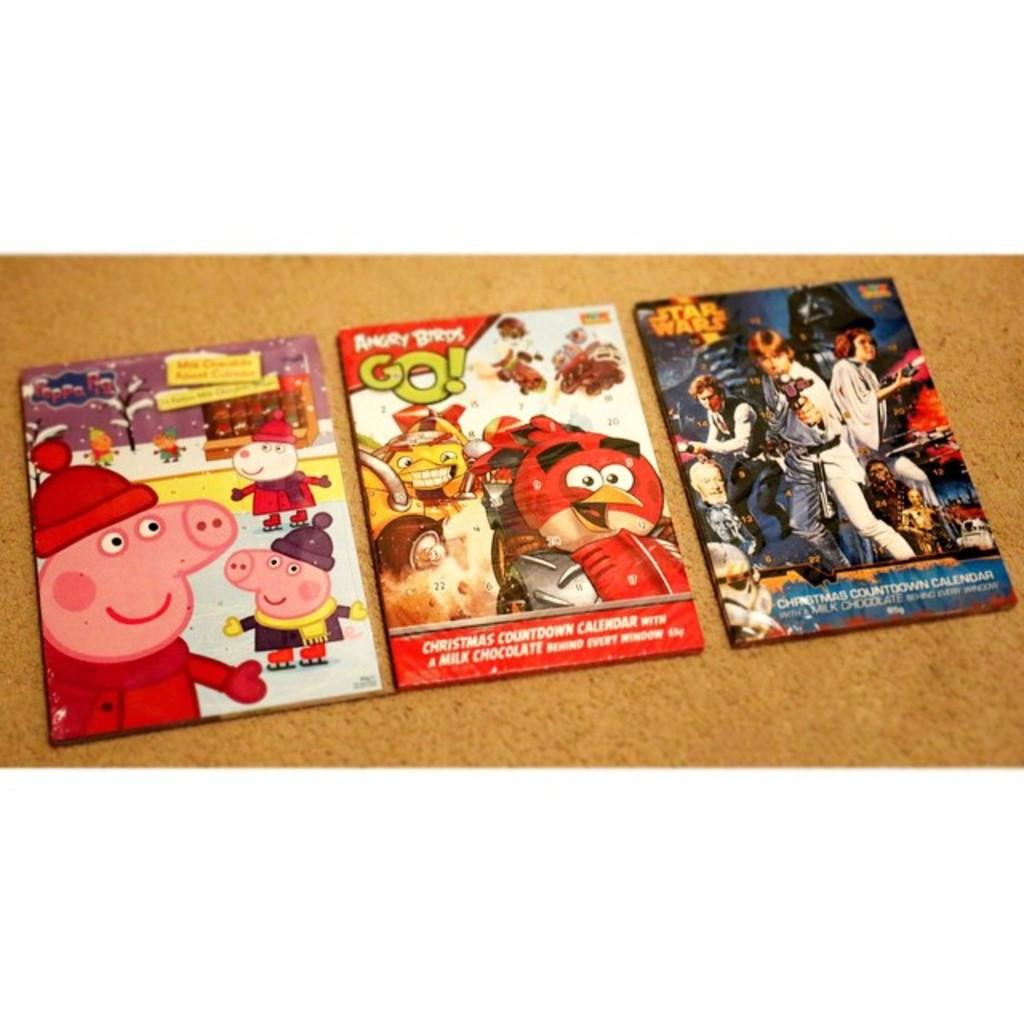What type of images are on the floor in the image? There are cartoon pictures on the floor. What color is the carpet on the floor? The carpet on the floor is white. What type of car can be seen driving through the cartoon pictures on the floor? There is no car present in the image; it only features cartoon pictures on the floor. What rock formation is visible in the image? There is no rock formation present in the image; it only features cartoon pictures on the floor and a white carpet. 